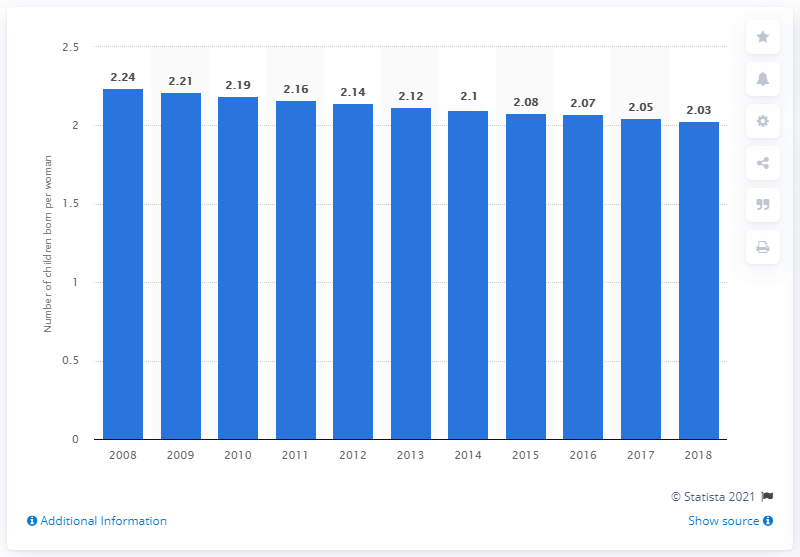Identify some key points in this picture. The fertility rate in Latin America and the Caribbean in 2018 was 2.03. 